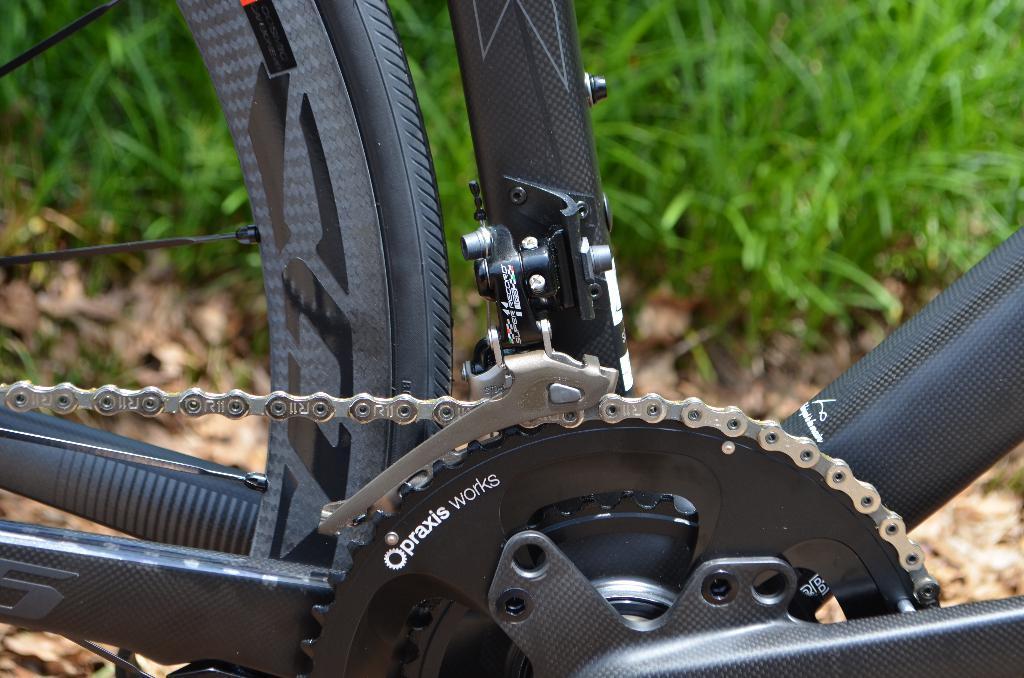Can you describe this image briefly? In the background we can see green grass. Here we can see partial part of a bicycle, chain and a tire. 